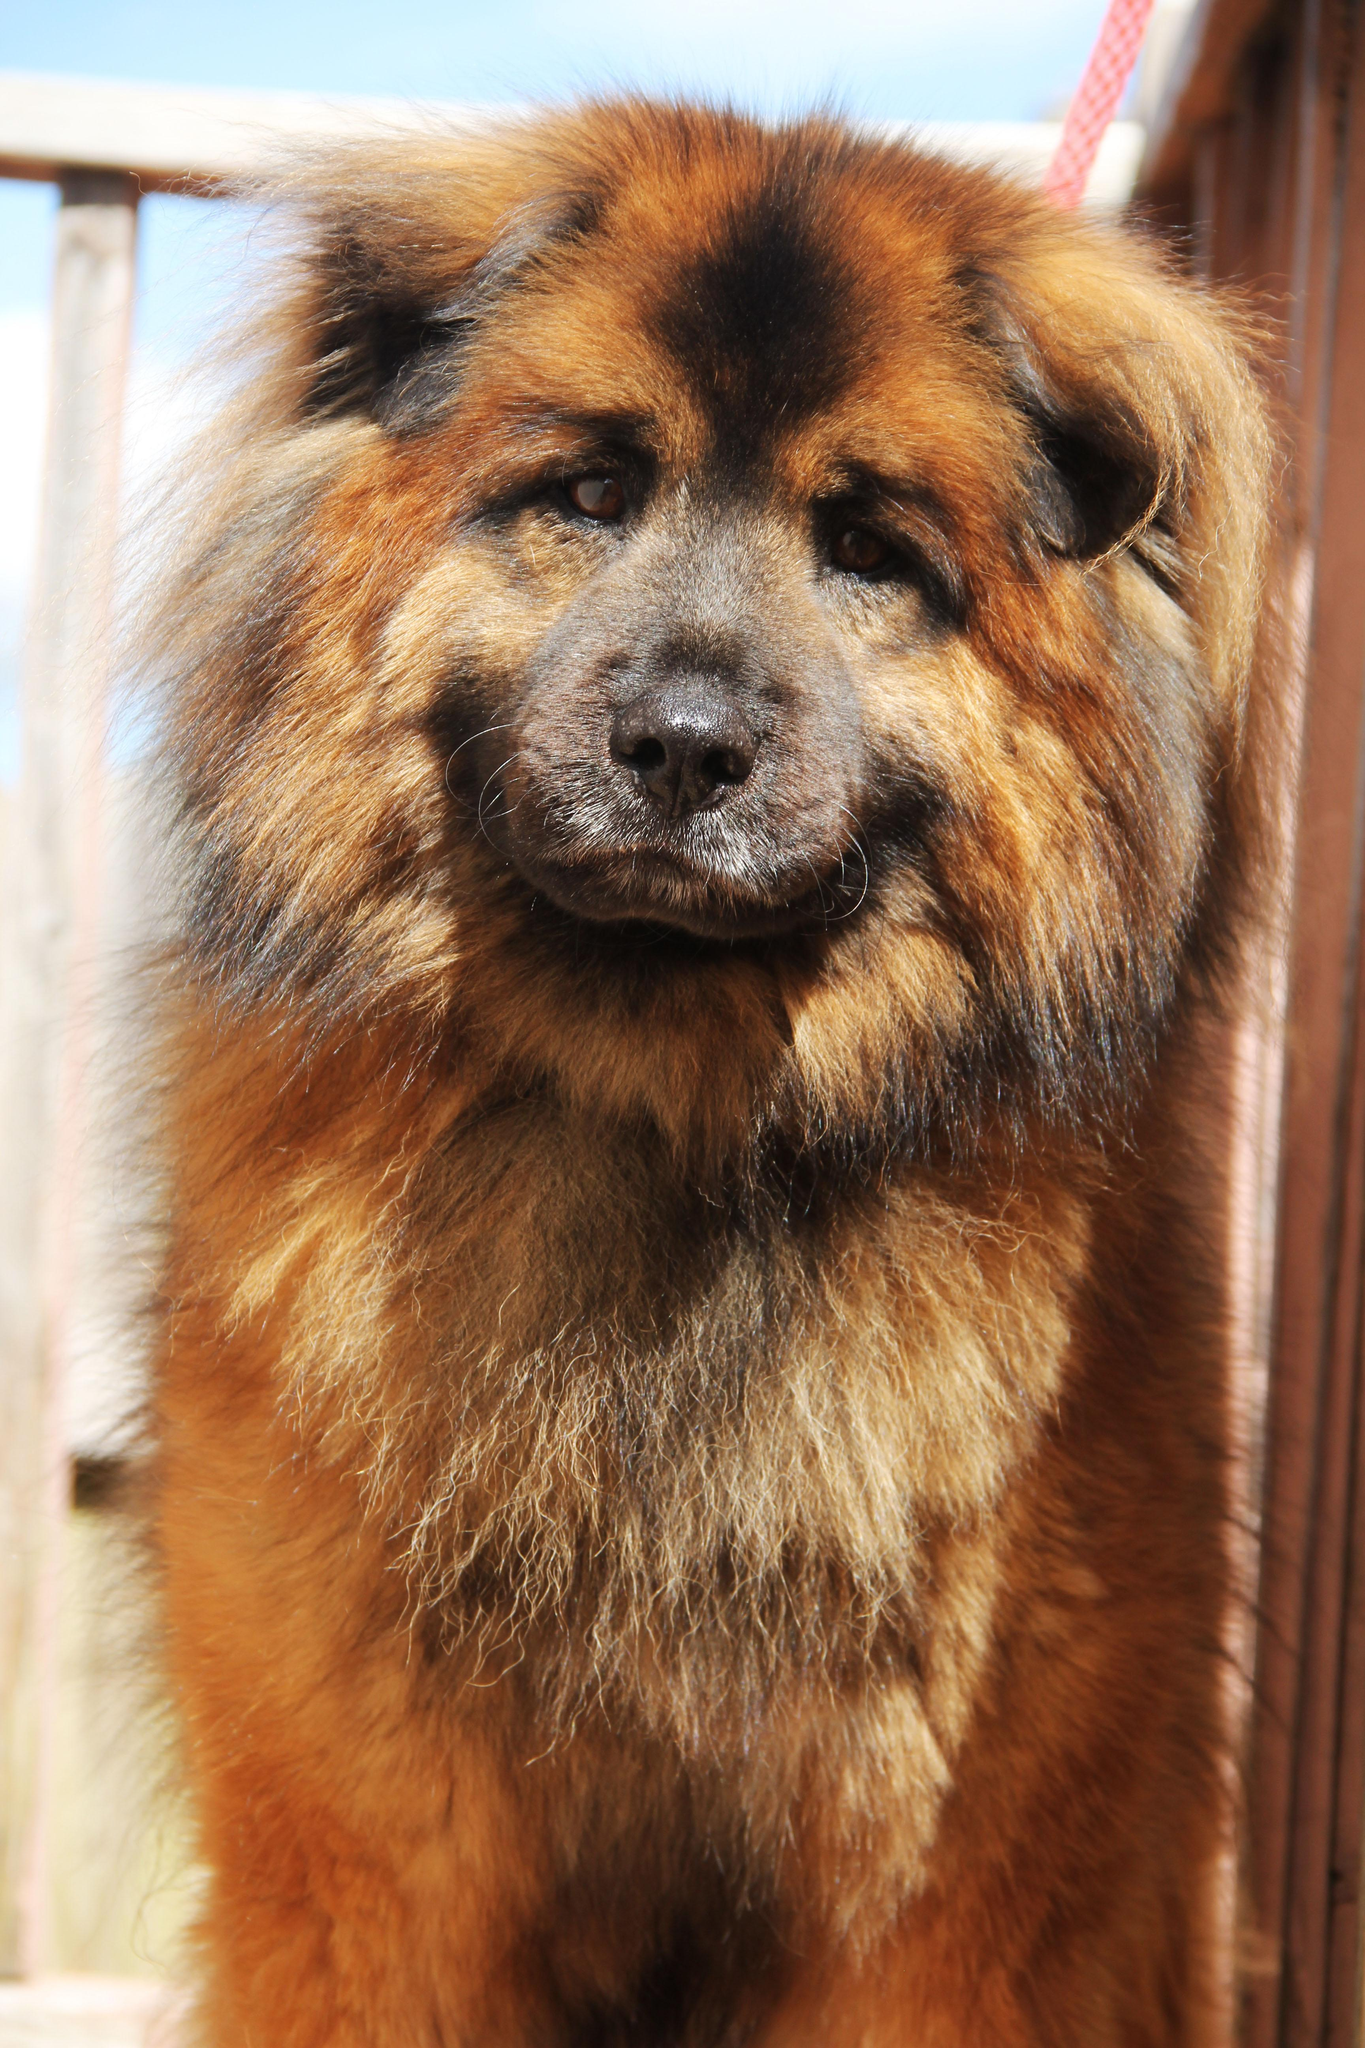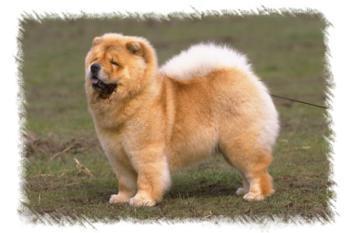The first image is the image on the left, the second image is the image on the right. Given the left and right images, does the statement "There are no less than two dogs in each image." hold true? Answer yes or no. No. The first image is the image on the left, the second image is the image on the right. Evaluate the accuracy of this statement regarding the images: "There are only two dogs.". Is it true? Answer yes or no. Yes. 